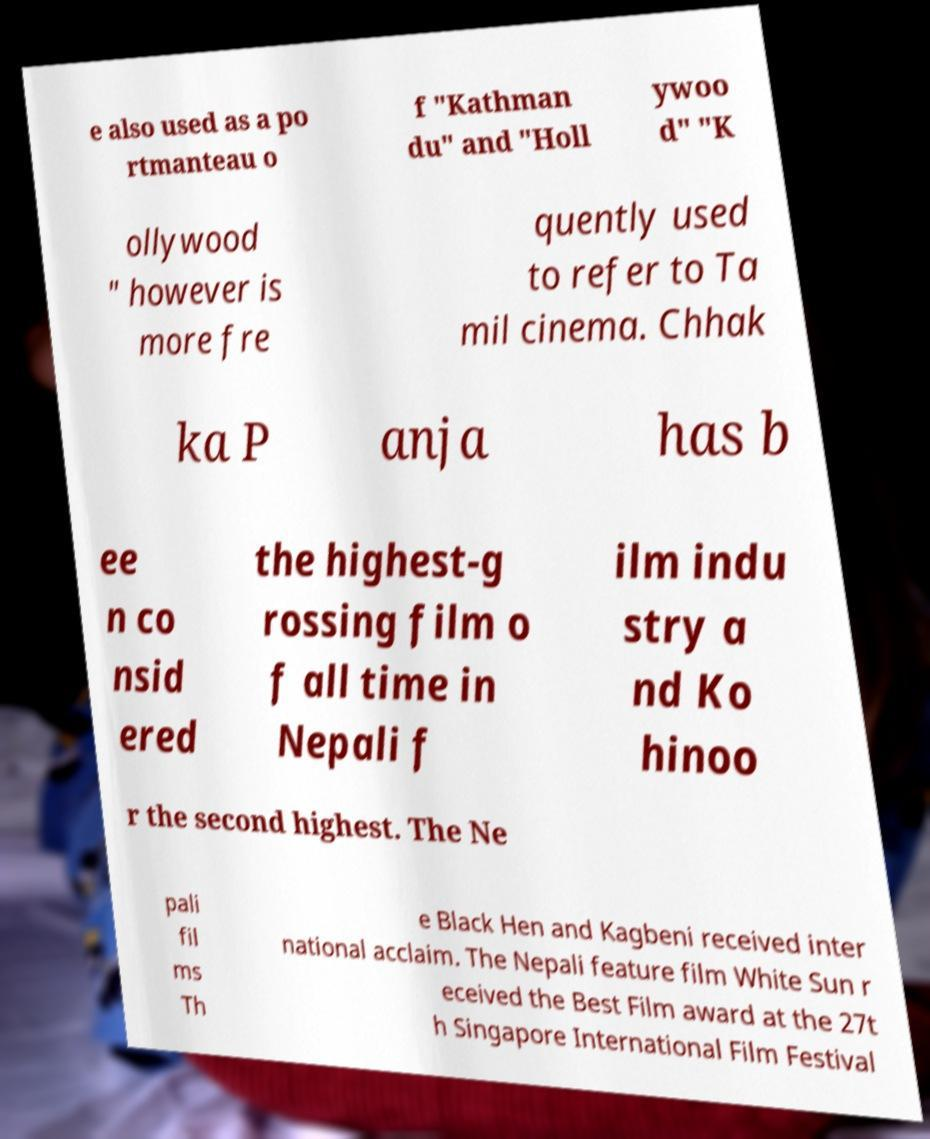What messages or text are displayed in this image? I need them in a readable, typed format. e also used as a po rtmanteau o f "Kathman du" and "Holl ywoo d" "K ollywood " however is more fre quently used to refer to Ta mil cinema. Chhak ka P anja has b ee n co nsid ered the highest-g rossing film o f all time in Nepali f ilm indu stry a nd Ko hinoo r the second highest. The Ne pali fil ms Th e Black Hen and Kagbeni received inter national acclaim. The Nepali feature film White Sun r eceived the Best Film award at the 27t h Singapore International Film Festival 